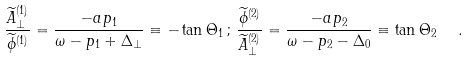<formula> <loc_0><loc_0><loc_500><loc_500>\frac { { \widetilde { A } } _ { \perp } ^ { ( 1 ) } } { { \widetilde { \phi } } ^ { ( 1 ) } } = \frac { - a p _ { 1 } } { \omega - p _ { 1 } + \Delta _ { \perp } } \equiv - \tan \Theta _ { 1 } \, ; \, \frac { { \widetilde { \phi } } ^ { ( 2 ) } } { { \widetilde { A } } _ { \perp } ^ { ( 2 ) } } = \frac { - a p _ { 2 } } { \omega - p _ { 2 } - \Delta _ { 0 } } \equiv \tan \Theta _ { 2 } \ \ .</formula> 